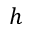<formula> <loc_0><loc_0><loc_500><loc_500>h</formula> 